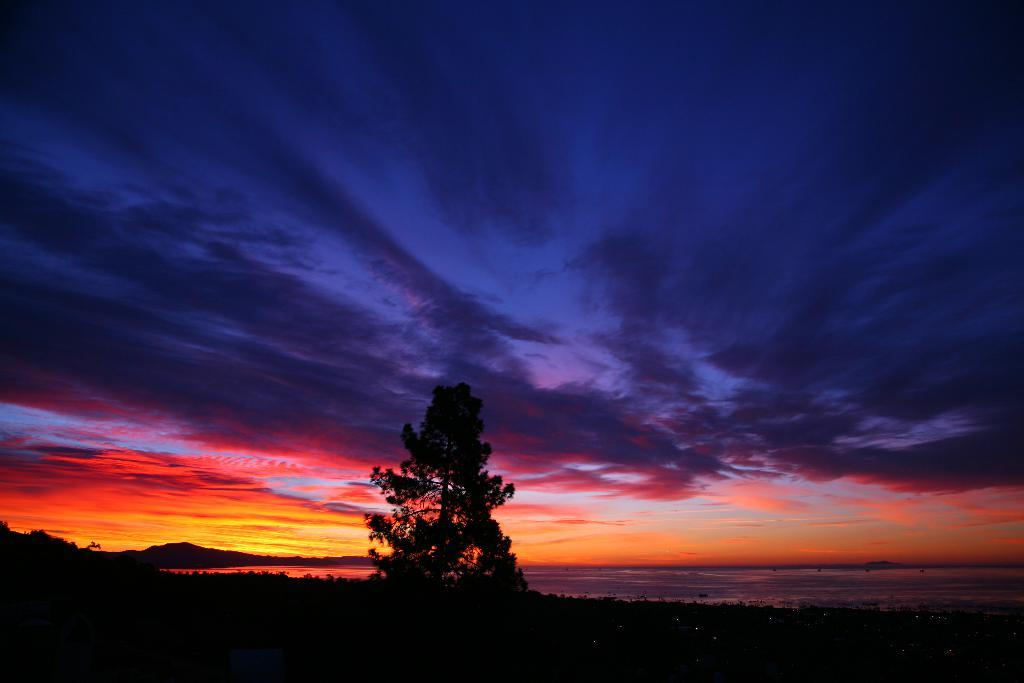How would you describe the lighting in the image? The image is a bit dark. What type of natural element can be seen in the image? There is a tree in the image. What can be seen in the sky in the image? The sky is visible and colorful in the image. What type of representative is depicted in the image? There is no representative present in the image; it features a tree and a colorful sky. What type of wealth is visible in the image? There is no wealth present in the image; it features a tree and a colorful sky. What type of war is being depicted in the image? There is no war being depicted in the image; it features a tree and a colorful sky. 